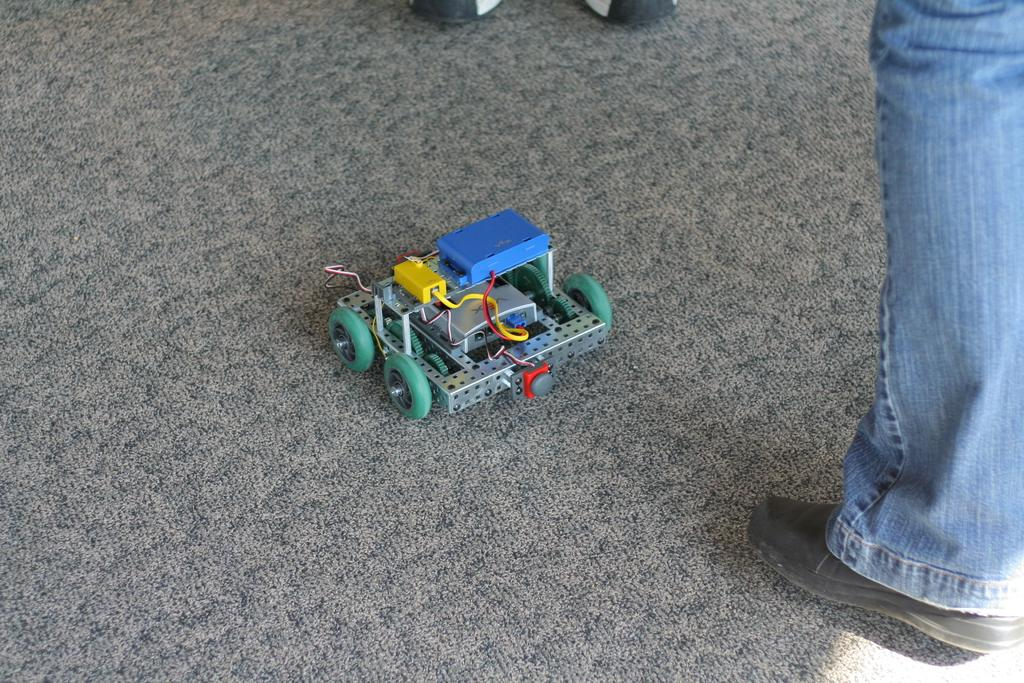What part of a person can be seen in the image? There is a person's leg in the image. What object is on the floor in the image? There is a toy vehicle on the floor in the image. What time is displayed on the clock in the image? There is no clock present in the image. What type of stew is being prepared in the image? There is no stew or cooking activity depicted in the image. 